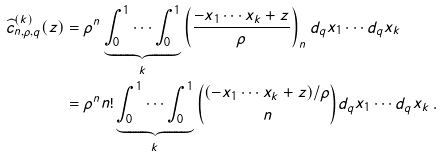Convert formula to latex. <formula><loc_0><loc_0><loc_500><loc_500>\widehat { c } _ { n , \rho , q } ^ { ( k ) } ( z ) & = \rho ^ { n } \underbrace { \int _ { 0 } ^ { 1 } \cdots \int _ { 0 } ^ { 1 } } _ { k } \left ( \frac { - x _ { 1 } \cdots x _ { k } + z } { \rho } \right ) _ { n } d _ { q } x _ { 1 } \cdots d _ { q } x _ { k } \\ & = \rho ^ { n } n ! \underbrace { \int _ { 0 } ^ { 1 } \cdots \int _ { 0 } ^ { 1 } } _ { k } \binom { ( - x _ { 1 } \cdots x _ { k } + z ) / \rho } { n } d _ { q } x _ { 1 } \cdots d _ { q } x _ { k } \, .</formula> 